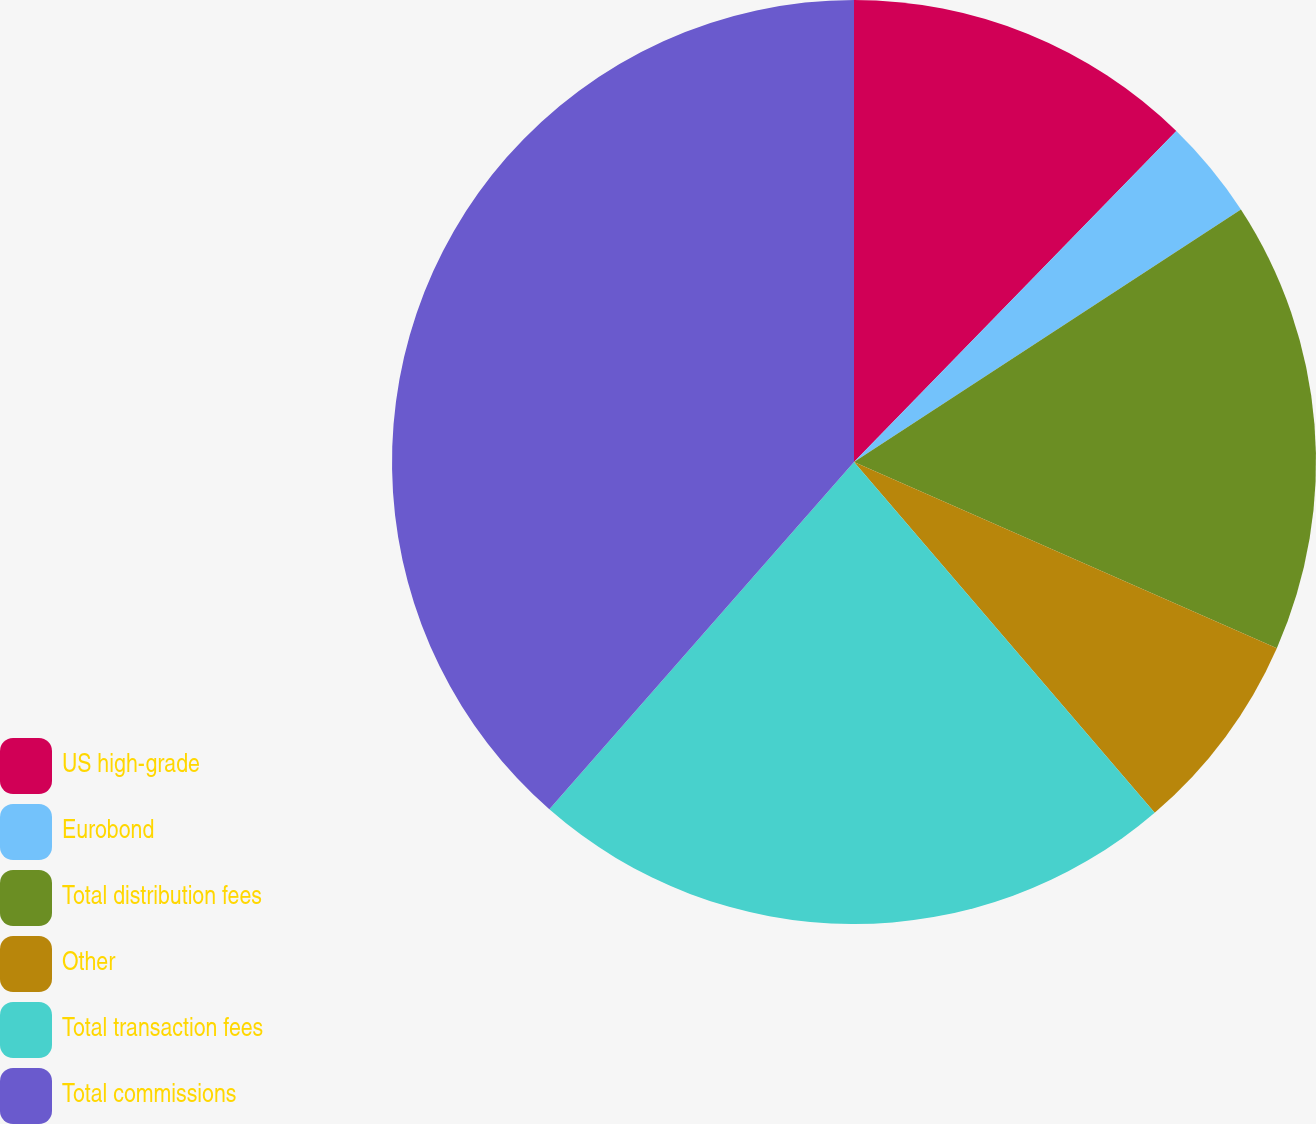<chart> <loc_0><loc_0><loc_500><loc_500><pie_chart><fcel>US high-grade<fcel>Eurobond<fcel>Total distribution fees<fcel>Other<fcel>Total transaction fees<fcel>Total commissions<nl><fcel>12.29%<fcel>3.51%<fcel>15.8%<fcel>7.12%<fcel>22.74%<fcel>38.54%<nl></chart> 